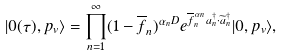Convert formula to latex. <formula><loc_0><loc_0><loc_500><loc_500>| 0 ( \tau ) , p _ { v } \rangle = \prod _ { n = 1 } ^ { \infty } ( 1 - \overline { f } _ { n } ) ^ { \alpha _ { n } D } e ^ { \overline { f } ^ { \, \alpha _ { n } } _ { n } a _ { n } ^ { \dagger } \cdot \widetilde { a } _ { n } ^ { \dagger } } | 0 , p _ { v } \rangle ,</formula> 